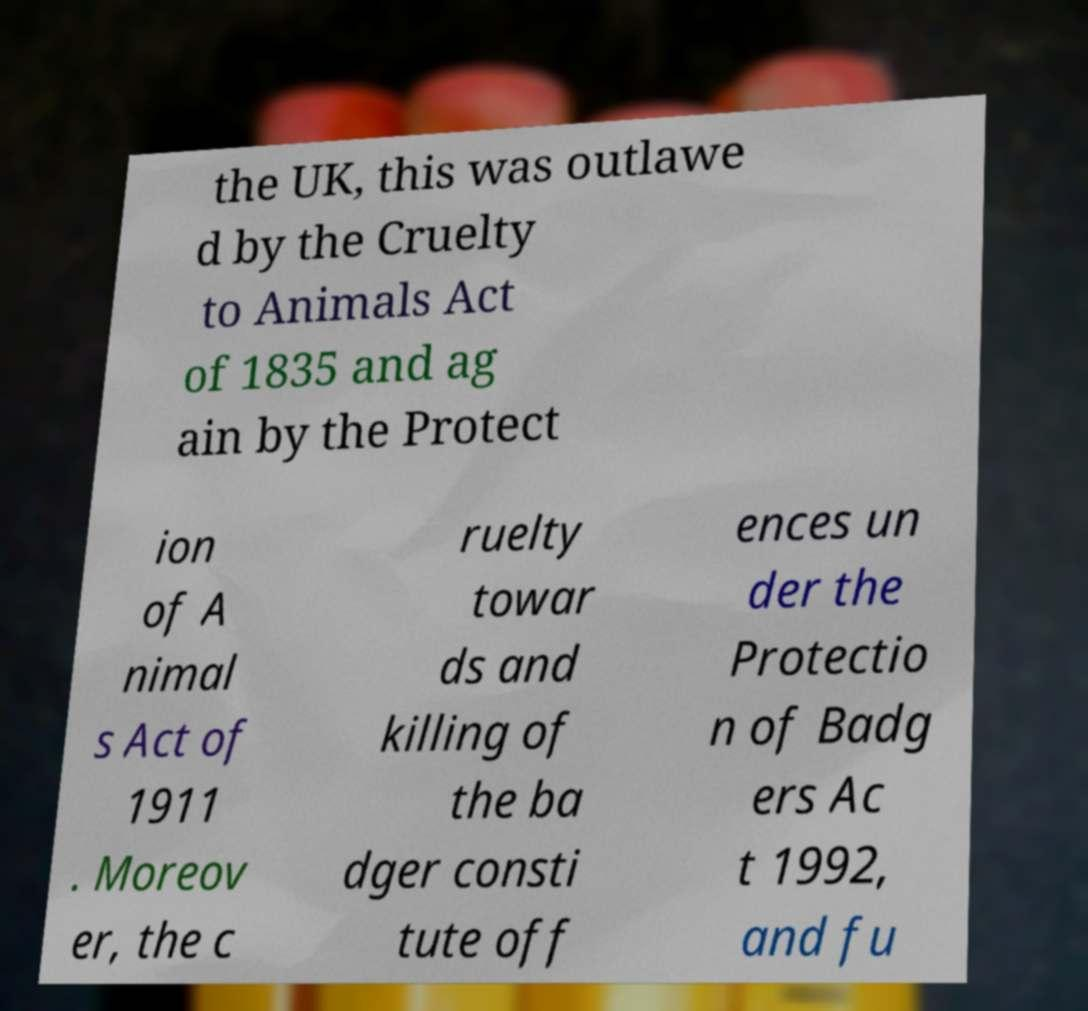Please identify and transcribe the text found in this image. the UK, this was outlawe d by the Cruelty to Animals Act of 1835 and ag ain by the Protect ion of A nimal s Act of 1911 . Moreov er, the c ruelty towar ds and killing of the ba dger consti tute off ences un der the Protectio n of Badg ers Ac t 1992, and fu 